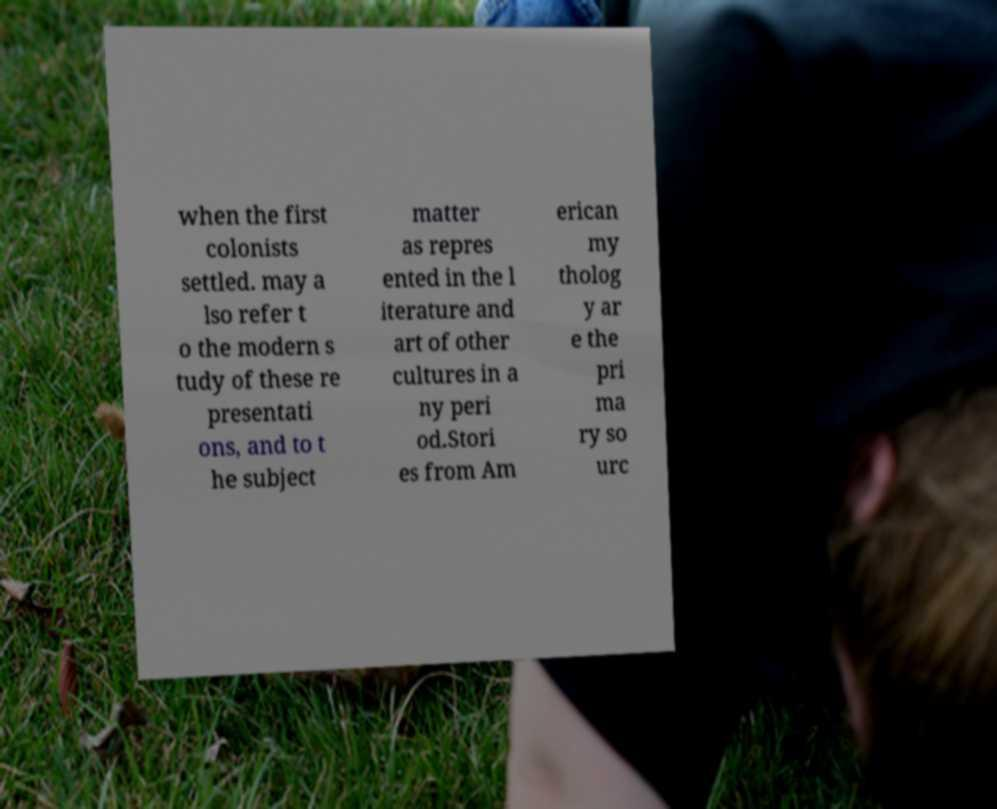Could you assist in decoding the text presented in this image and type it out clearly? when the first colonists settled. may a lso refer t o the modern s tudy of these re presentati ons, and to t he subject matter as repres ented in the l iterature and art of other cultures in a ny peri od.Stori es from Am erican my tholog y ar e the pri ma ry so urc 